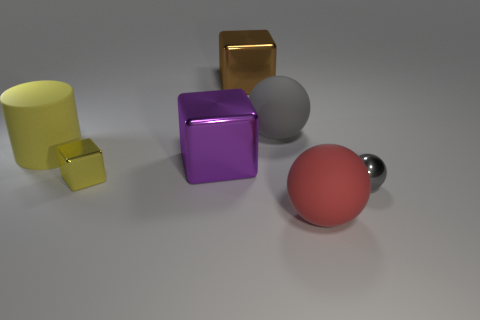Add 2 large matte balls. How many objects exist? 9 Subtract all cylinders. How many objects are left? 6 Add 1 gray metal balls. How many gray metal balls exist? 2 Subtract 1 red balls. How many objects are left? 6 Subtract all large matte objects. Subtract all red matte spheres. How many objects are left? 3 Add 4 small gray metal balls. How many small gray metal balls are left? 5 